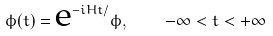<formula> <loc_0><loc_0><loc_500><loc_500>\phi ( t ) = \text {e} ^ { - i H t / } \phi , \quad - \infty < t < + \infty</formula> 